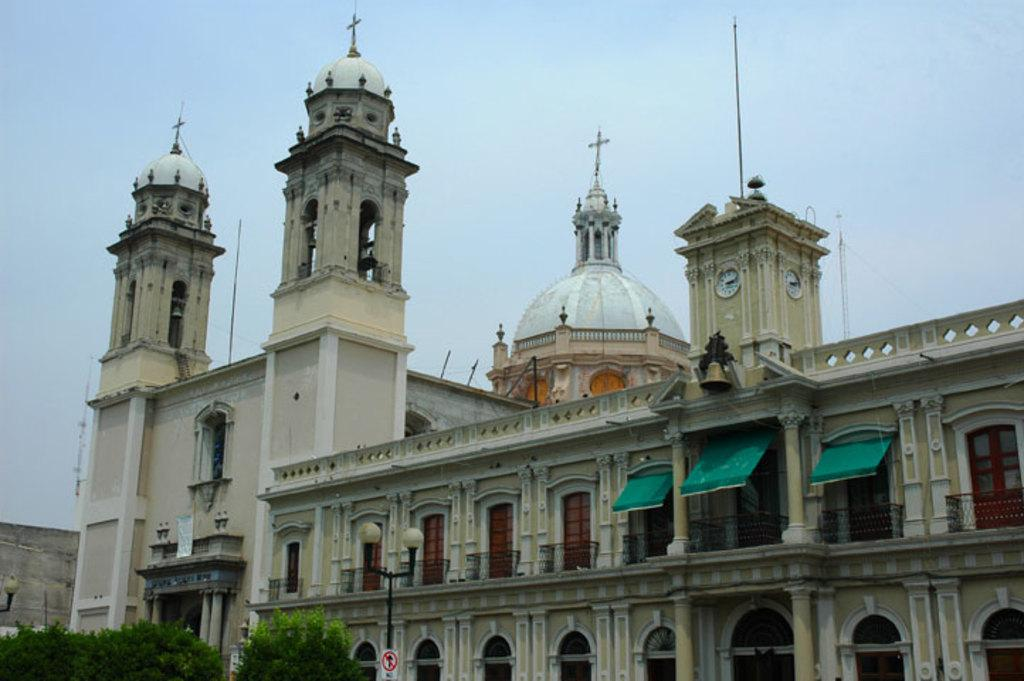What type of building is in the image? There is a church in the image. What features can be seen on the church? The church has windows, doors, a clock, and a bell at the top. Where are the plants and light pole located in the image? They are in the bottom left of the image. Who is the writer of the book that can be seen on the church's altar in the image? There is no book or writer mentioned in the image; it only features a church with specific architectural elements and plants and a light pole in the bottom left corner. 